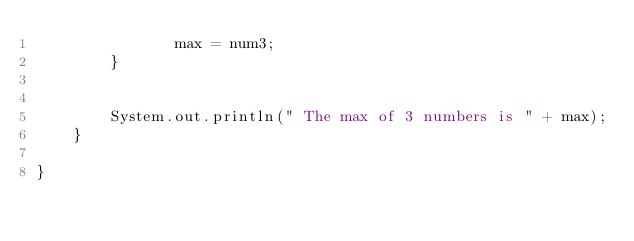Convert code to text. <code><loc_0><loc_0><loc_500><loc_500><_Java_>               max = num3;
        }
     

        System.out.println(" The max of 3 numbers is " + max);
    }

}
</code> 